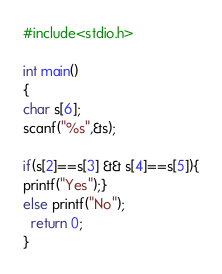<code> <loc_0><loc_0><loc_500><loc_500><_C_>#include<stdio.h>
 
int main()
{
char s[6];
scanf("%s",&s);

if(s[2]==s[3] && s[4]==s[5]){
printf("Yes");}
else printf("No");
  return 0;
}</code> 